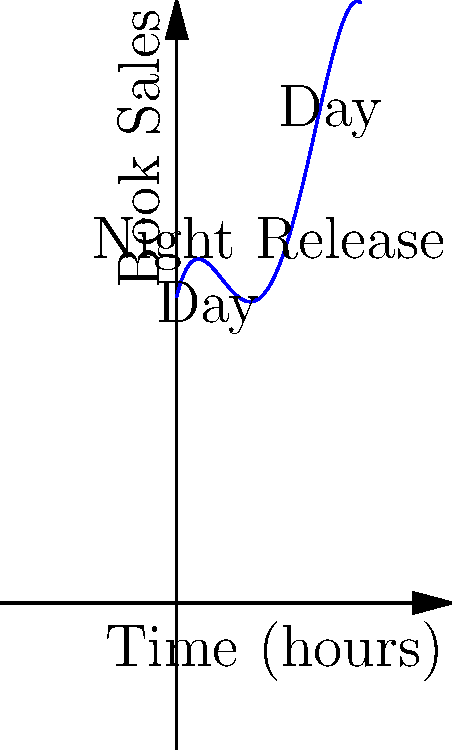The polynomial function $f(x) = -0.1x^4 + 1.2x^3 - 4x^2 + 4x + 10$ represents book sales over a 24-hour period, where $x$ is the time in hours starting from midnight. Based on the graph, which shows higher sales during nighttime releases, at what time does the maximum number of sales occur? To find the time of maximum sales, we need to follow these steps:

1) The maximum point on the graph corresponds to the highest peak.

2) Visually, we can see that this peak occurs around $x = 3$.

3) To be more precise, we need to find the derivative of the function and set it to zero:

   $f'(x) = -0.4x^3 + 3.6x^2 - 8x + 4$

4) Setting $f'(x) = 0$:

   $-0.4x^3 + 3.6x^2 - 8x + 4 = 0$

5) This cubic equation is difficult to solve by hand, but using a calculator or computer algebra system, we find that the solution closest to $x = 3$ is approximately $x = 3.0986$.

6) Since $x$ represents hours since midnight, we convert this to time:

   $3.0986 \approx 3$ hours and $(0.0986 * 60) \approx 6$ minutes past midnight

Therefore, the maximum number of sales occurs at approximately 3:06 AM.
Answer: 3:06 AM 